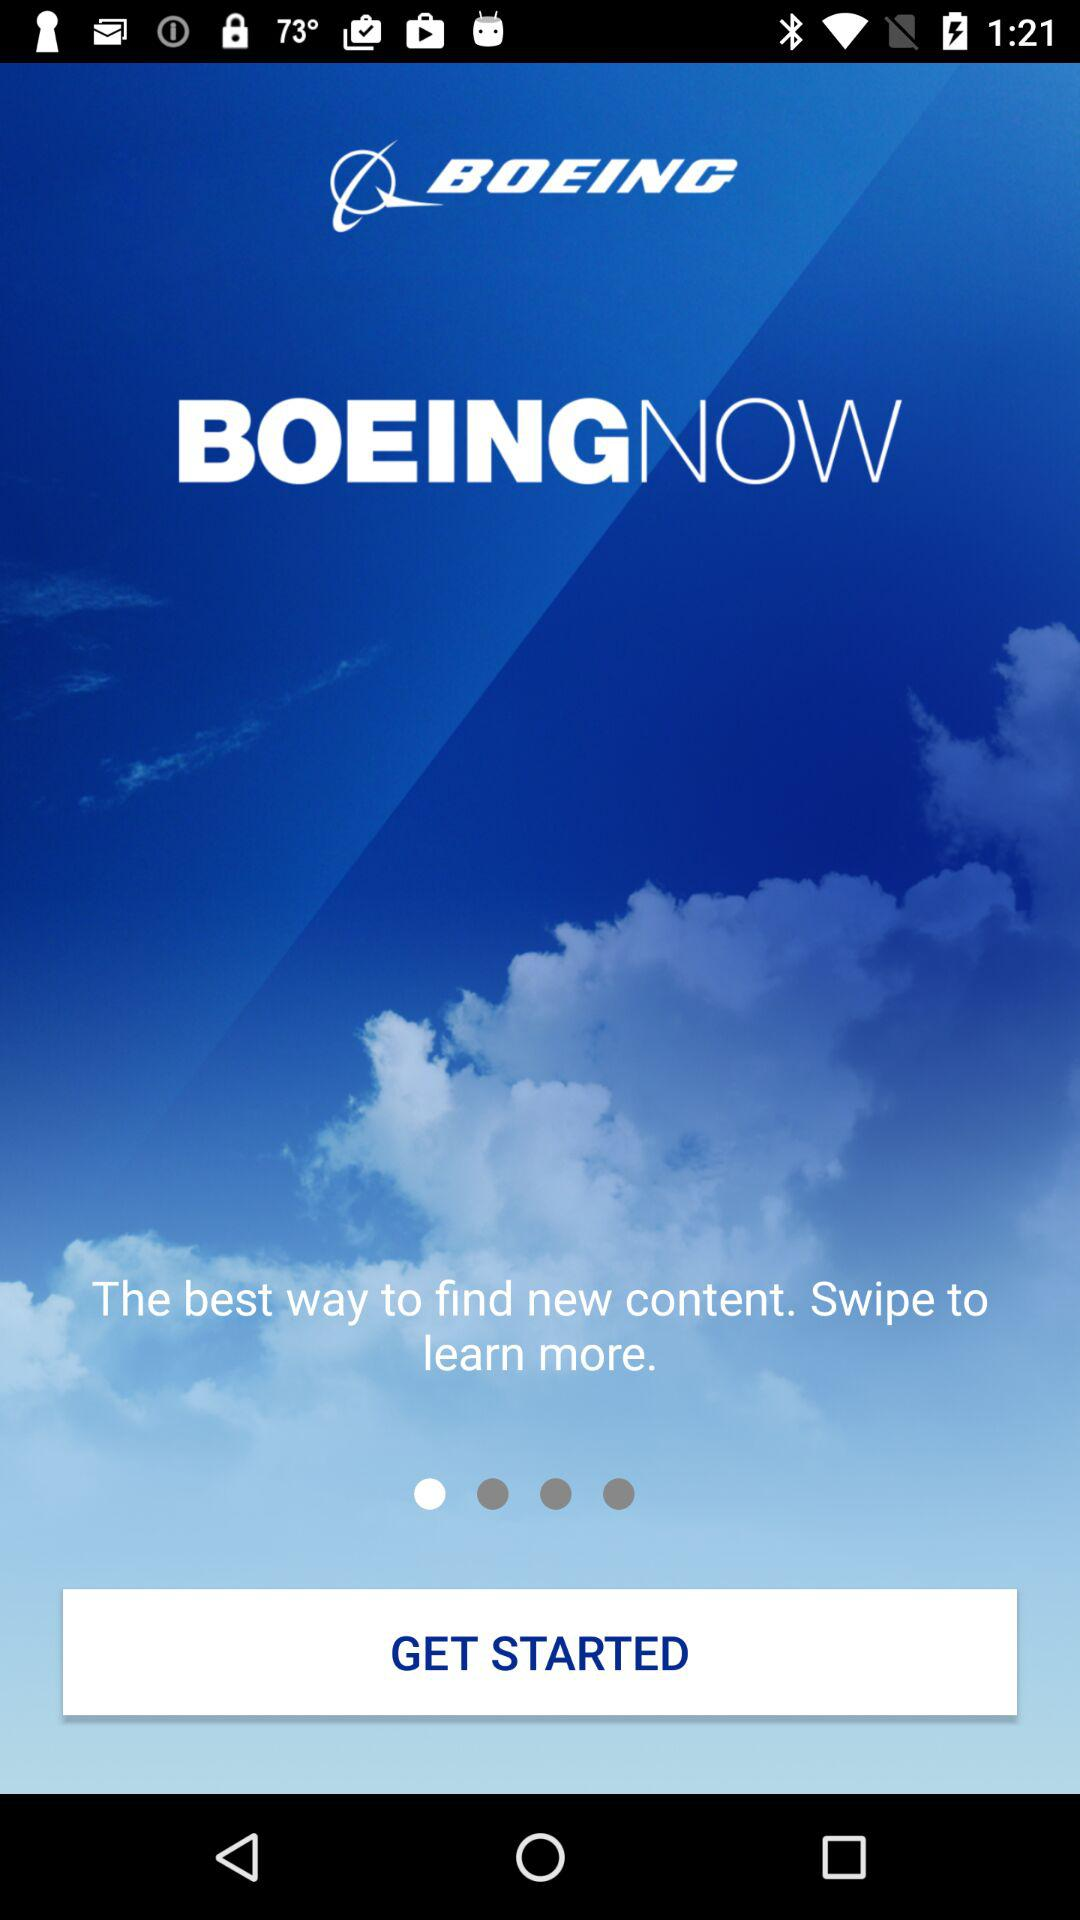How much does "BOEING" cost?
When the provided information is insufficient, respond with <no answer>. <no answer> 